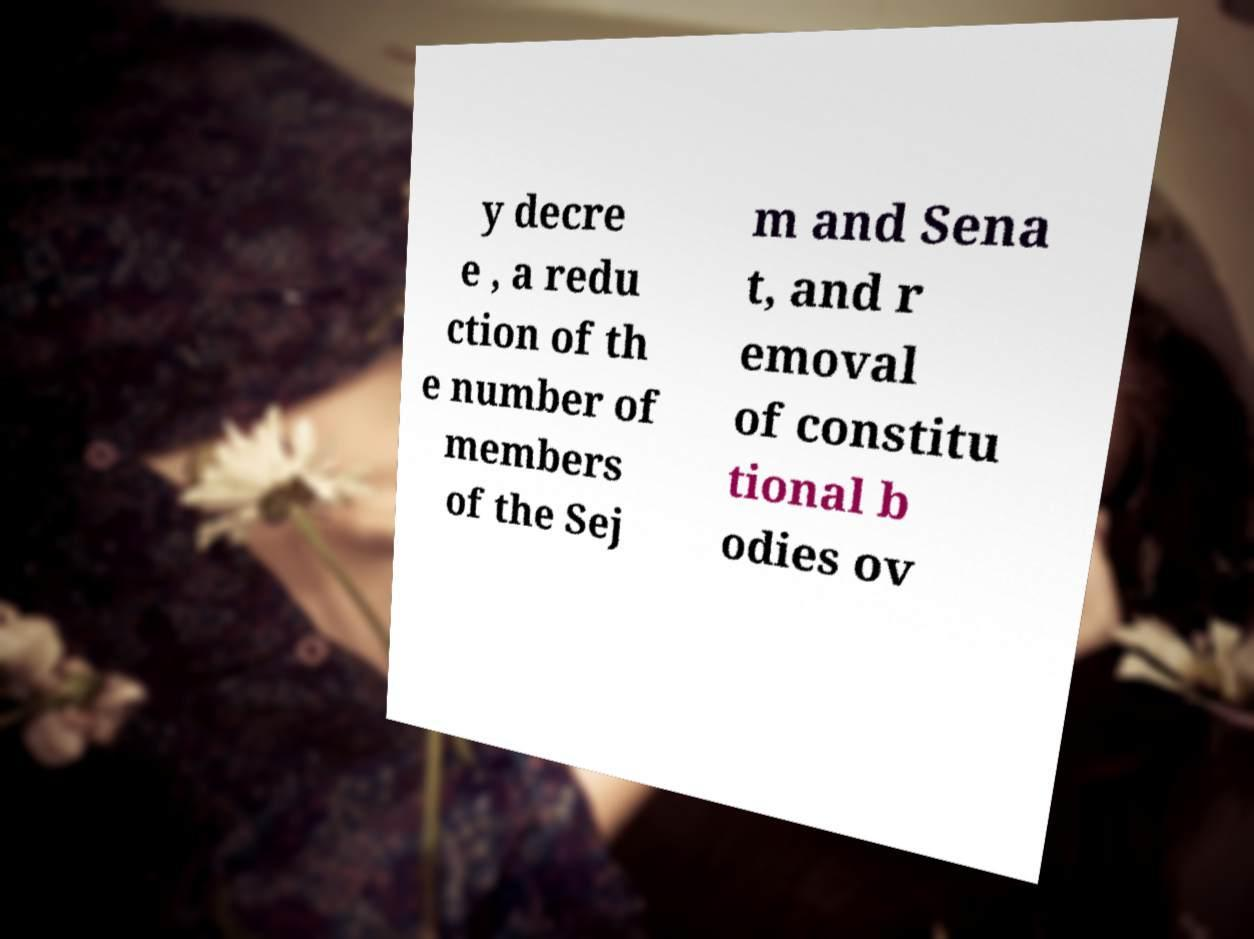There's text embedded in this image that I need extracted. Can you transcribe it verbatim? y decre e , a redu ction of th e number of members of the Sej m and Sena t, and r emoval of constitu tional b odies ov 